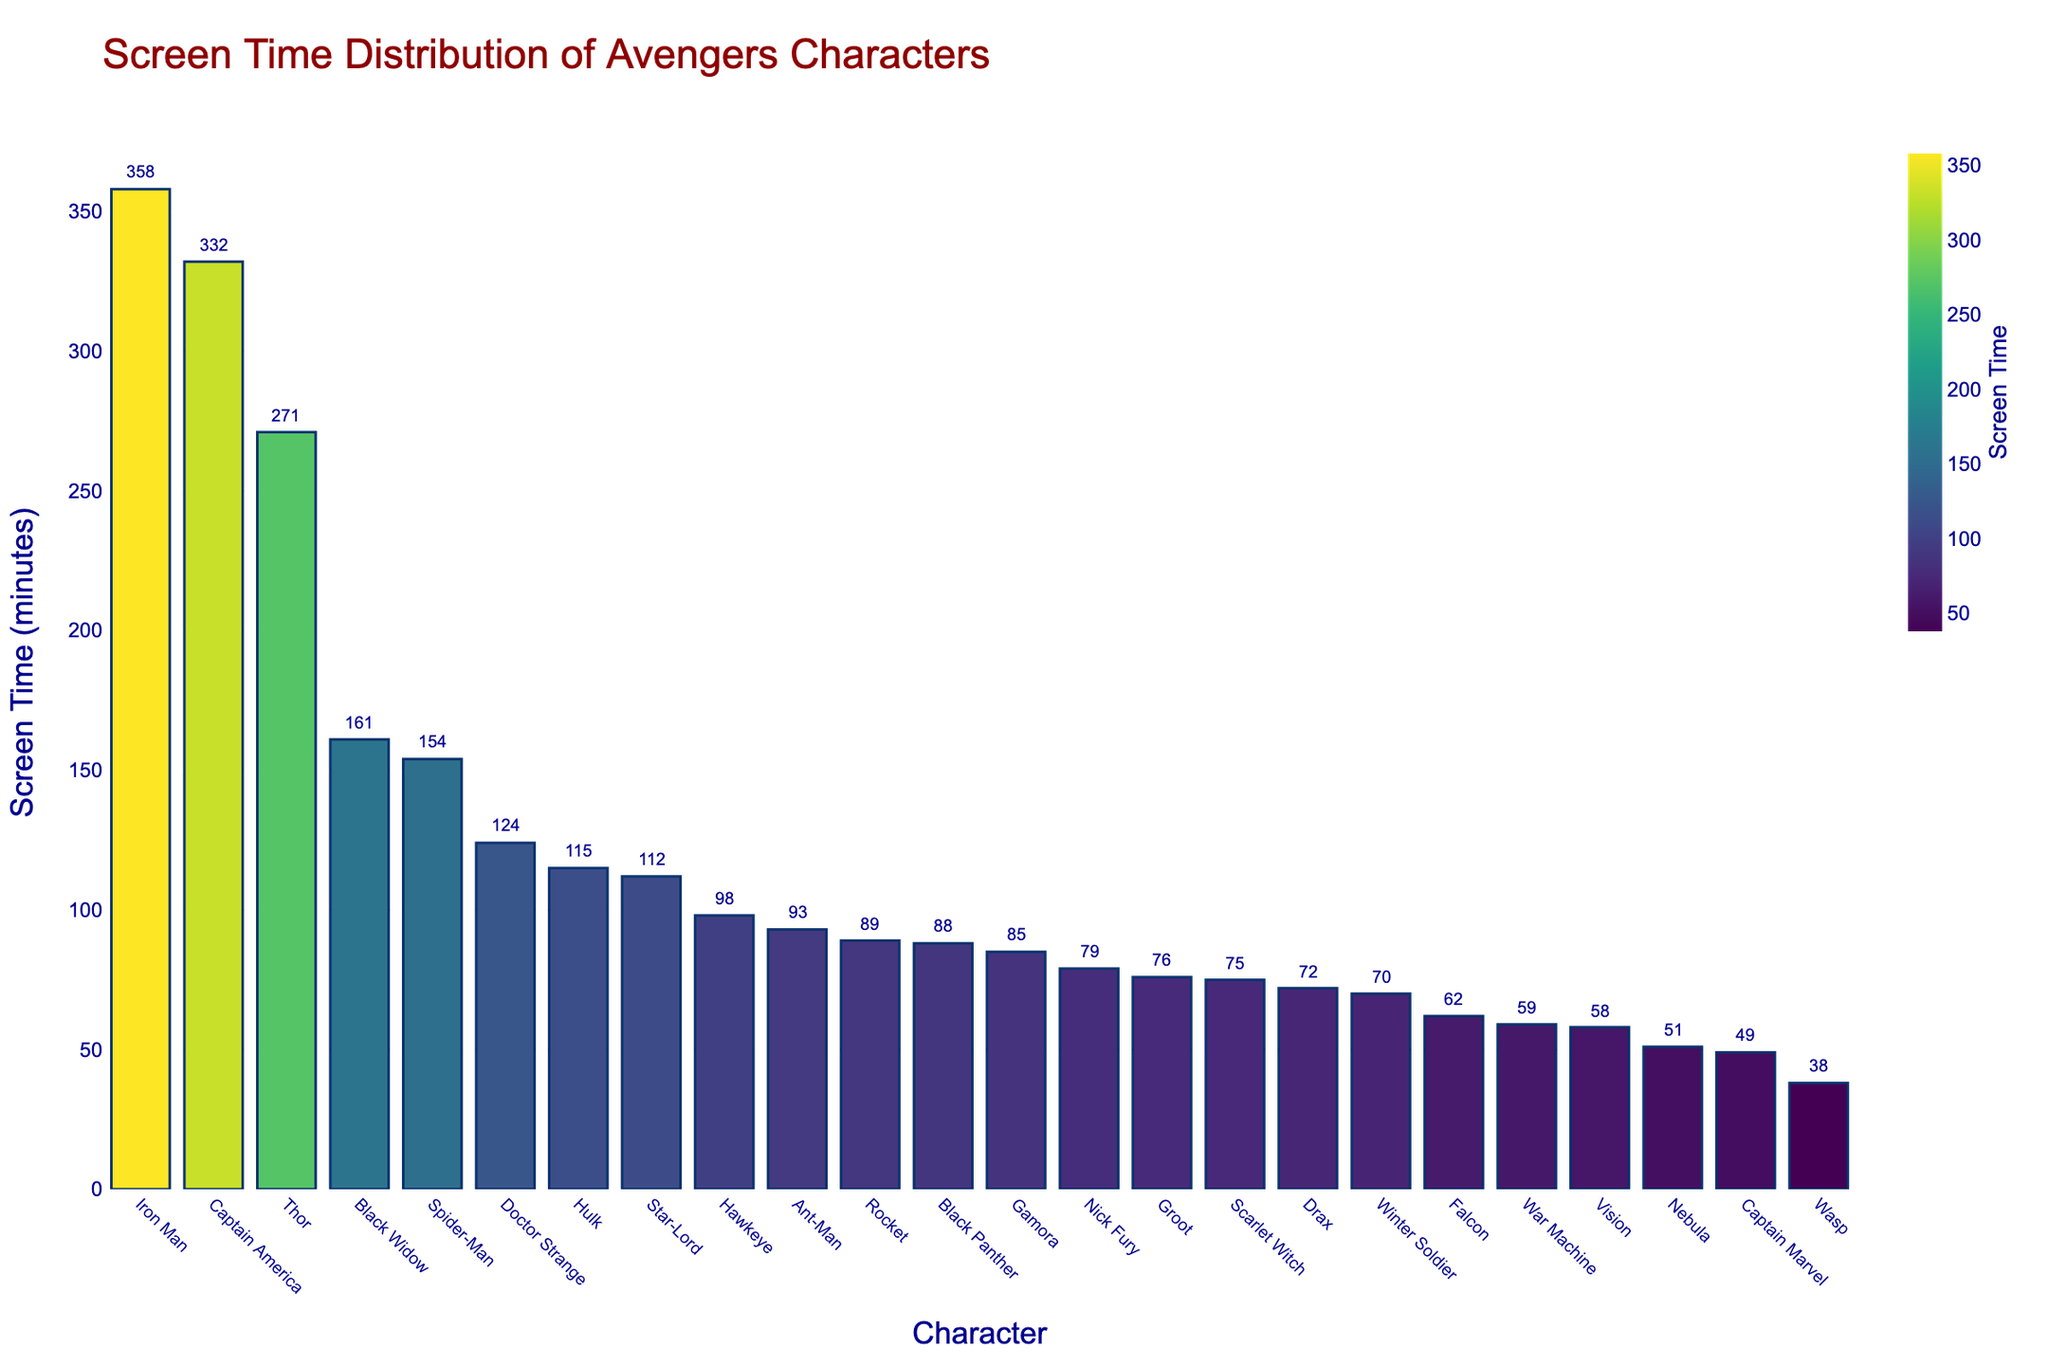What's the average screen time of the top four characters? The top four characters are Iron Man, Captain America, Thor, and Black Widow. Their respective screen times are 358, 332, 271, and 161 minutes. The sum is 358 + 332 + 271 + 161 = 1122. Dividing by 4 gives the average screen time: 1122 / 4 = 280.5 minutes
Answer: 280.5 Which character has the highest screen time? The character with the highest bar, and thus the highest screen time, is Iron Man. He has 358 minutes of screen time.
Answer: Iron Man What is the difference in screen time between Spider-Man and Doctor Strange? Spider-Man has 154 minutes of screen time, and Doctor Strange has 124 minutes. The difference is 154 - 124 = 30 minutes.
Answer: 30 Which two characters have the closest screen times, and what are those screen times? War Machine and Vision have the closest screen times. War Machine has 59 minutes, and Vision has 58 minutes. The difference is only 1 minute.
Answer: War Machine (59) and Vision (58) How many characters have more than 100 minutes of screen time? Characters with more than 100 minutes of screen time are Iron Man, Captain America, Thor, Black Widow, Spider-Man, and Doctor Strange. There are 6 characters.
Answer: 6 Compare the screen time of Black Panther and Scarlet Witch. Who has more, and by how much? Black Panther has 88 minutes, and Scarlet Witch has 75 minutes of screen time. Black Panther has 13 more minutes than Scarlet Witch.
Answer: Black Panther by 13 What's the total screen time for the characters with the lowest three screen times? The characters with the lowest screen times are Wasp (38 minutes), Captain Marvel (49 minutes), and Nebula (51 minutes). The total is 38 + 49 + 51 = 138 minutes.
Answer: 138 Are there more characters with less than 100 minutes or more than 100 minutes of screen time? Calculating those with less than 100 minutes: Black Widow, Hulk, Hawkeye, Black Panther, Captain Marvel, Scarlet Witch, Vision, Falcon, Winter Soldier, War Machine, Wasp, Groot, Star-Lord, Gamora, Drax, Rocket, Nebula, and Nick Fury (17 characters). Calculating those with more than 100 minutes: Iron Man, Captain America, Thor, Spider-Man, Doctor Strange (5 characters). There are more characters with less than 100 minutes of screen time.
Answer: Less than 100 What is the average screen time of the bottom five characters? The bottom five characters are Wasp (38), Captain Marvel (49), Nebula (51), Vision (58), and War Machine (59). The sum is 38 + 49 + 51 + 58 + 59 = 255. The average is 255 / 5 = 51 minutes.
Answer: 51 